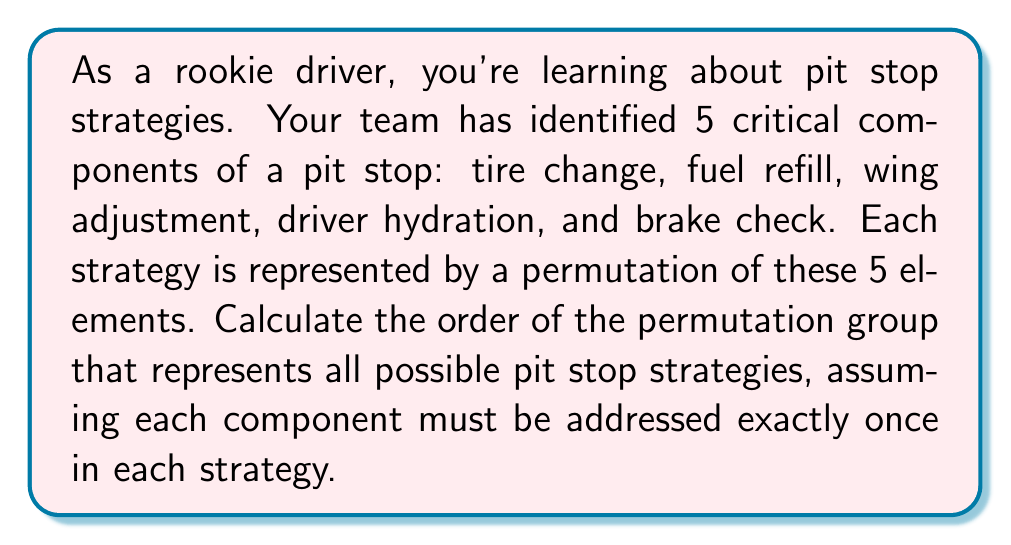Help me with this question. To solve this problem, we need to understand the concept of permutation groups and how to calculate their order.

1) First, let's identify what we're dealing with:
   We have 5 distinct elements (tire change, fuel refill, wing adjustment, driver hydration, brake check) that can be arranged in different orders.

2) In permutation group theory, when we have n distinct elements that can be arranged in any order, we're dealing with the symmetric group $S_n$.

3) In this case, we have 5 elements, so we're working with $S_5$.

4) The order of a symmetric group $S_n$ is given by $n!$ (n factorial).

5) Therefore, the order of $S_5$ is:

   $$|S_5| = 5! = 5 \times 4 \times 3 \times 2 \times 1 = 120$$

6) This means there are 120 different possible permutations, or in the context of our problem, 120 different pit stop strategies.

Each of these 120 permutations represents a unique order in which the 5 pit stop components can be performed. For example, one permutation might be (tire change, fuel refill, wing adjustment, driver hydration, brake check), while another might be (brake check, wing adjustment, tire change, driver hydration, fuel refill).
Answer: The order of the permutation group representing all possible pit stop strategies is 120. 